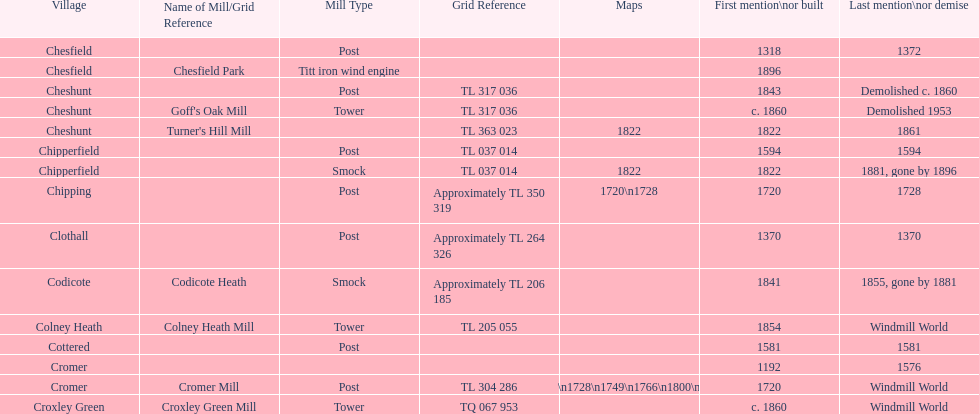How many locations have or had at least 2 windmills? 4. 